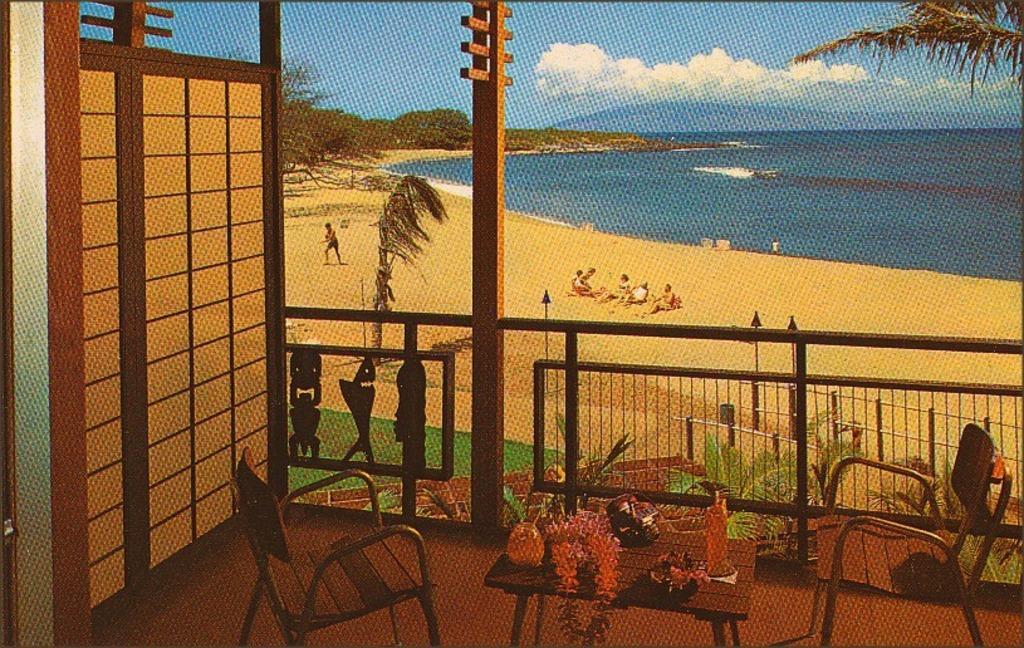Can you describe this image briefly? In this image there is a grille, table, chairs, trees, plants, water, people, cloudy sky and things. On the table there are objects. 